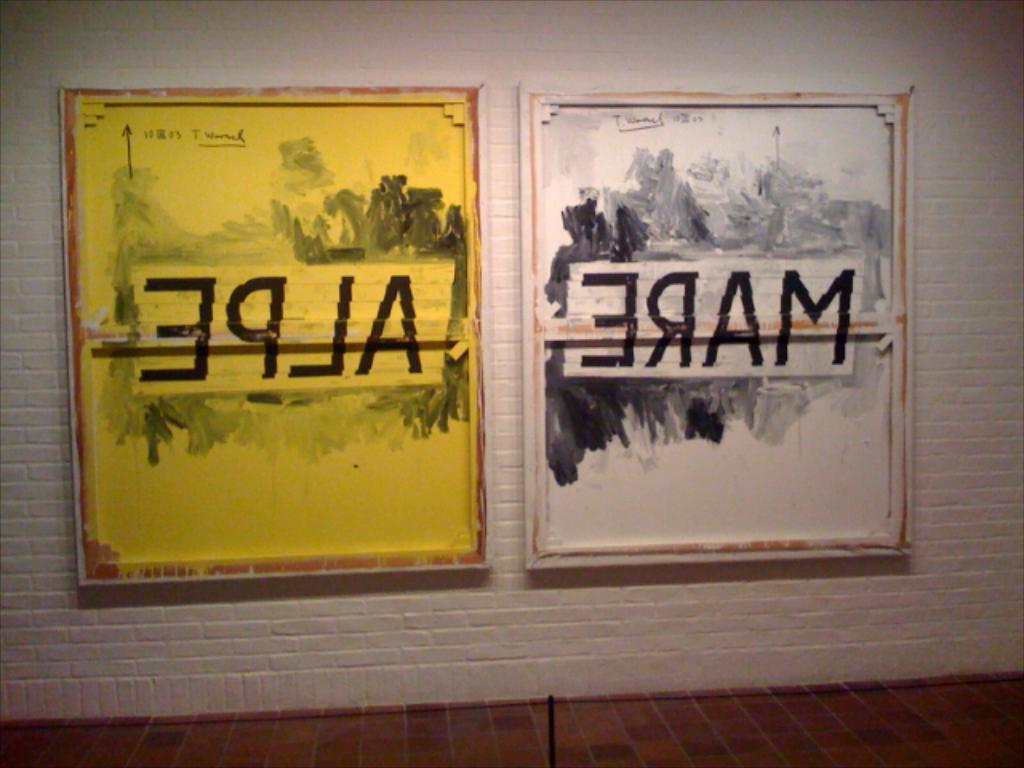<image>
Write a terse but informative summary of the picture. Two posters with backwards letters that spell out EPLA and ERAM. 